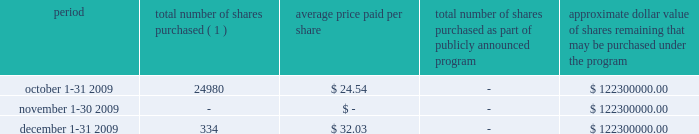We are required under the terms of our preferred stock to pay scheduled quarterly dividends , subject to legally available funds .
For so long as the preferred stock remains outstanding , ( 1 ) we will not declare , pay or set apart funds for the payment of any dividend or other distribution with respect to any junior stock or parity stock and ( 2 ) neither we , nor any of our subsidiaries , will , subject to certain exceptions , redeem , purchase or otherwise acquire for consideration junior stock or parity stock through a sinking fund or otherwise , in each case unless we have paid or set apart funds for the payment of all accumulated and unpaid dividends with respect to the shares of preferred stock and any parity stock for all preceding dividend periods .
Pursuant to this policy , we paid quarterly dividends of $ 0.265625 per share on our preferred stock on february 1 , 2009 , may 1 , 2009 , august 3 , 2009 and november 2 , 2009 and similar quarterly dividends during each quarter of 2008 .
The annual cash dividend declared and paid during the years ended december 31 , 2009 and 2008 were $ 10 million and $ 10 million , respectively .
On january 5 , 2010 , we declared a cash dividend of $ 0.265625 per share on our preferred stock amounting to $ 3 million and a cash dividend of $ 0.04 per share on our series a common stock amounting to $ 6 million .
Both cash dividends are for the period from november 2 , 2009 to january 31 , 2010 and were paid on february 1 , 2010 to holders of record as of january 15 , 2010 .
On february 1 , 2010 , we announced we would elect to redeem all of our outstanding preferred stock on february 22 , 2010 .
Holders of the preferred stock also have the right to convert their shares at any time prior to 5:00 p.m. , new york city time , on february 19 , 2010 , the business day immediately preceding the february 22 , 2010 redemption date .
Based on the number of outstanding shares as of december 31 , 2009 and considering the redemption of our preferred stock , cash dividends to be paid in 2010 are expected to result in annual dividend payments less than those paid in 2009 .
The amount available to us to pay cash dividends is restricted by our senior credit agreement .
Any decision to declare and pay dividends in the future will be made at the discretion of our board of directors and will depend on , among other things , our results of operations , cash requirements , financial condition , contractual restrictions and other factors that our board of directors may deem relevant .
Celanese purchases of its equity securities the table below sets forth information regarding repurchases of our series a common stock during the three months ended december 31 , 2009 : period total number of shares purchased ( 1 ) average price paid per share total number of shares purchased as part of publicly announced program approximate dollar value of shares remaining that may be purchased under the program .
( 1 ) relates to shares employees have elected to have withheld to cover their statutory minimum withholding requirements for personal income taxes related to the vesting of restricted stock units .
No shares were purchased during the three months ended december 31 , 2009 under our previously announced stock repurchase plan .
%%transmsg*** transmitting job : d70731 pcn : 033000000 ***%%pcmsg|33 |00012|yes|no|02/10/2010 05:41|0|0|page is valid , no graphics -- color : n| .
What is the total amount spent for the purchased shares during october 2009? 
Computations: (24980 * 24.54)
Answer: 613009.2. 